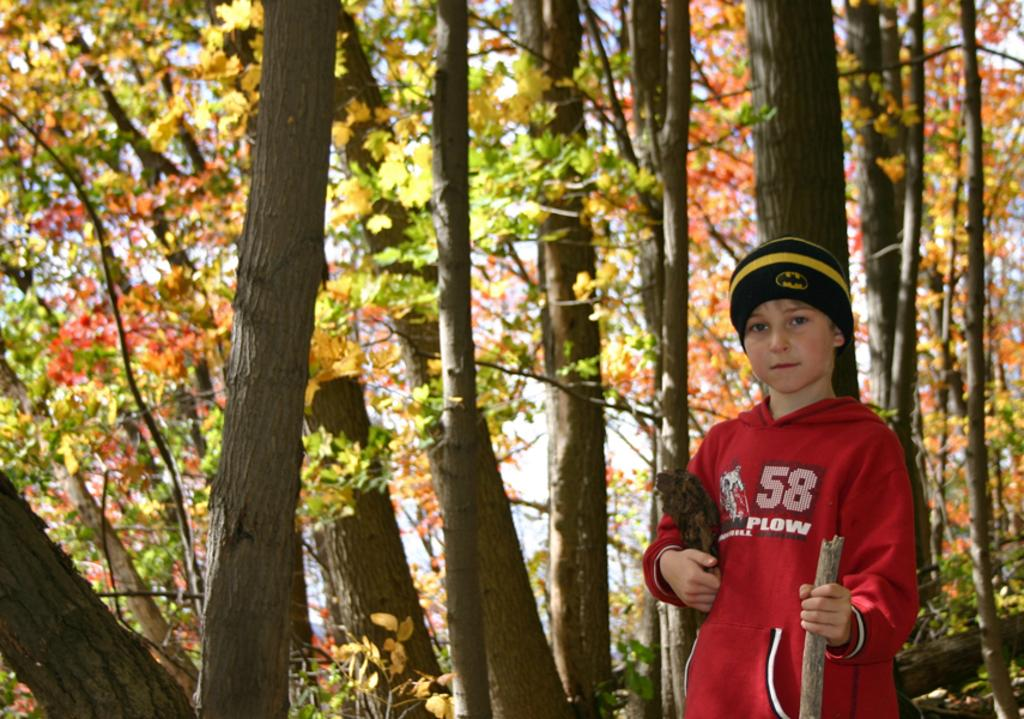<image>
Describe the image concisely. a boy in the woods with a hat and hooding saying 58 plow 